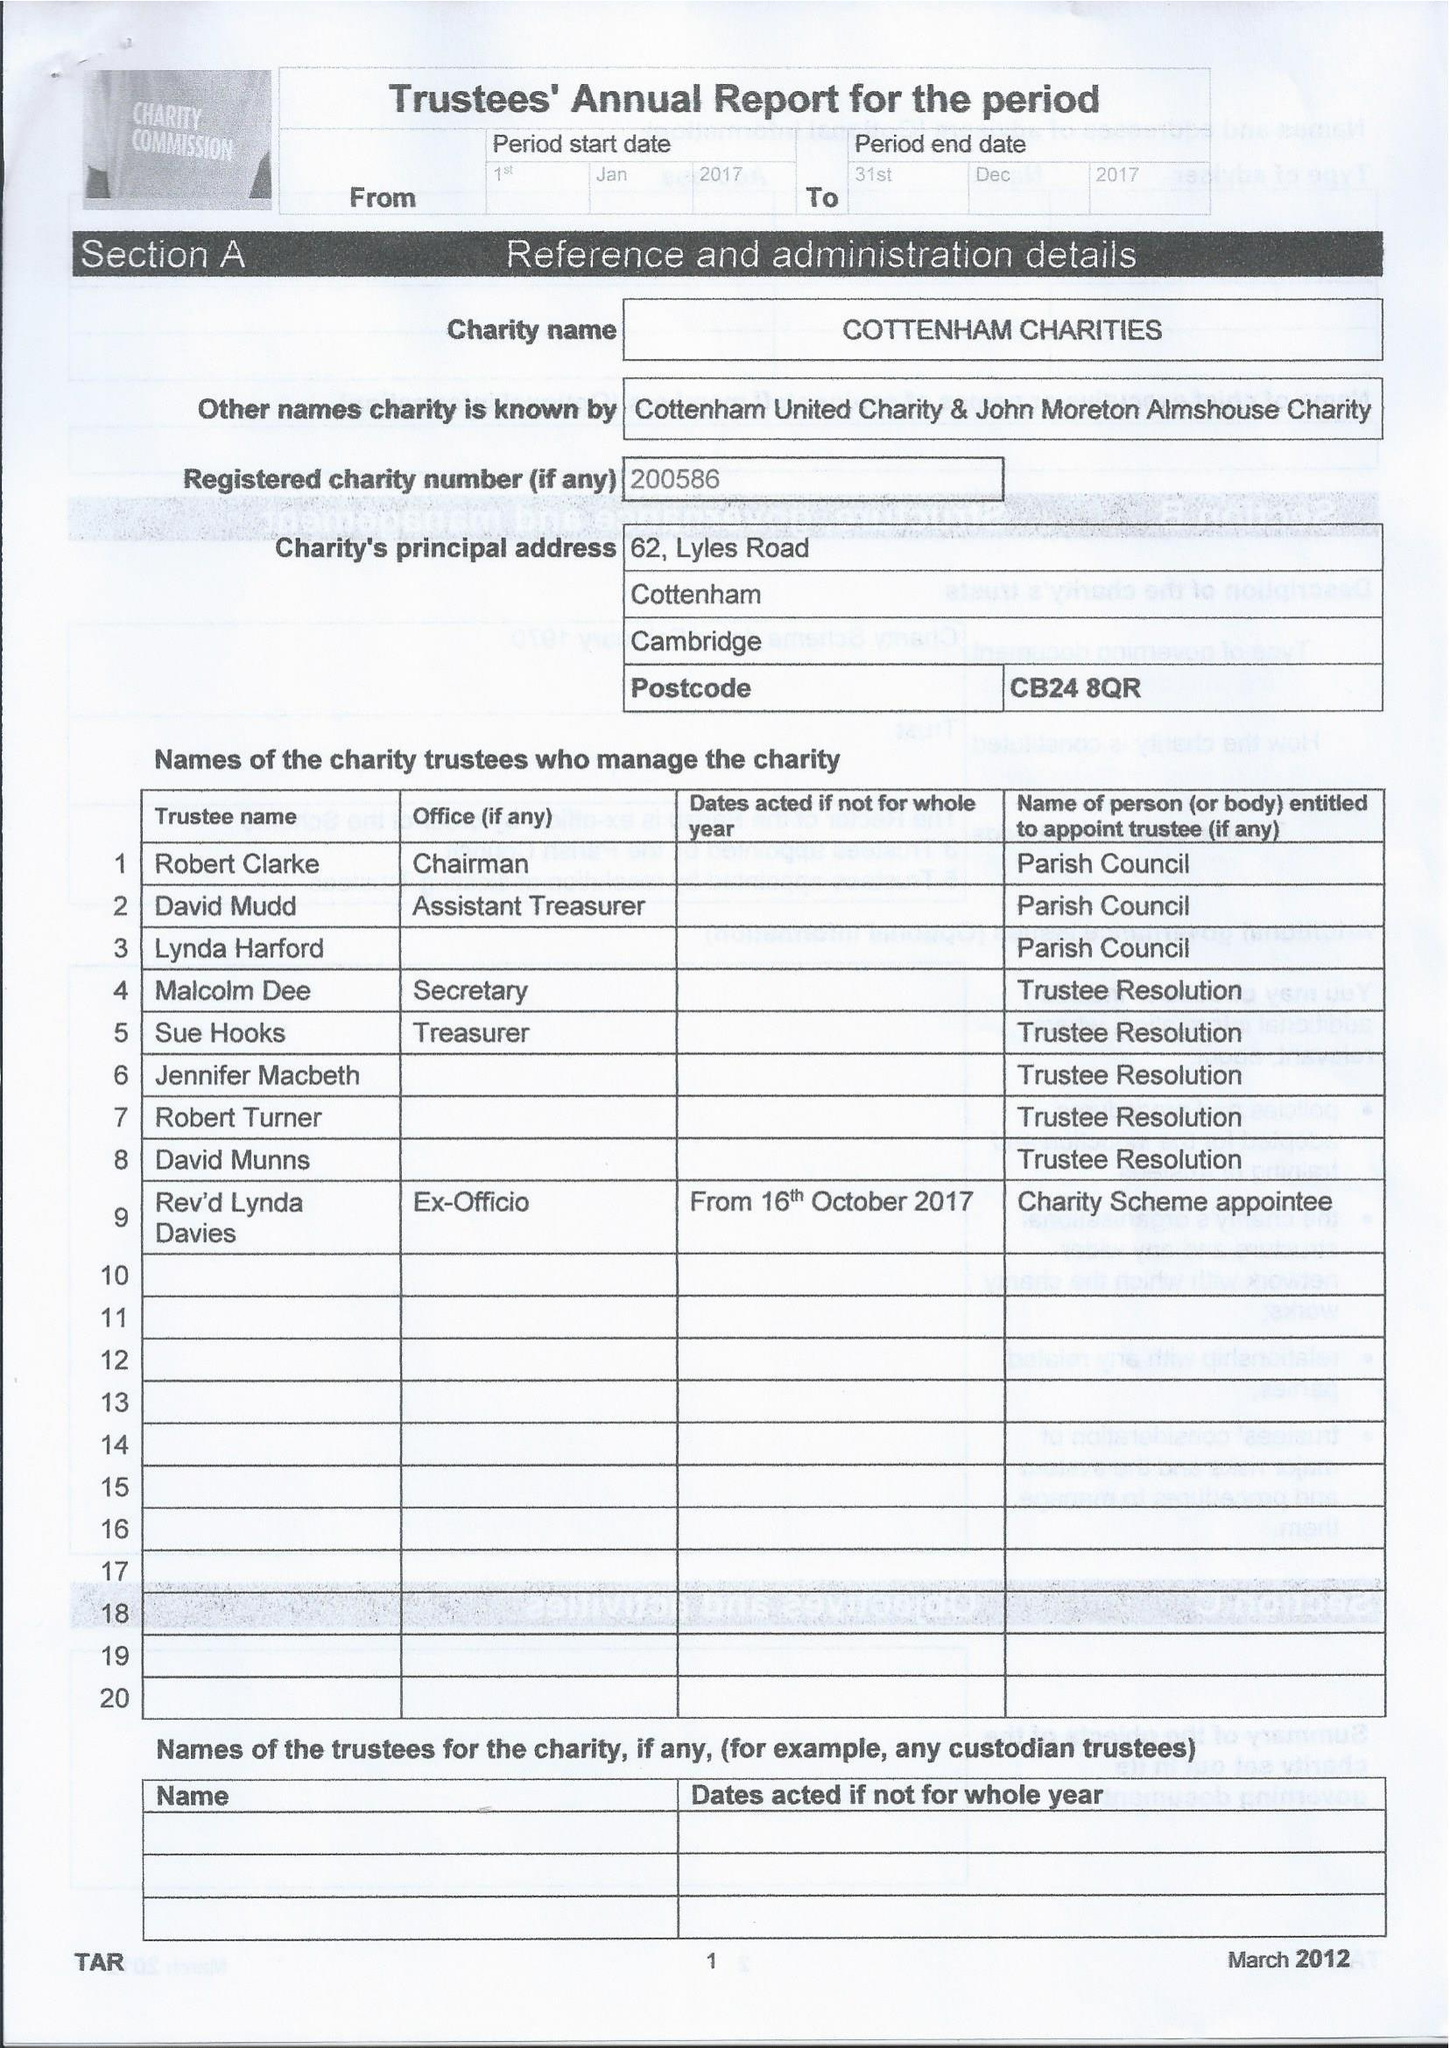What is the value for the report_date?
Answer the question using a single word or phrase. 2017-12-31 